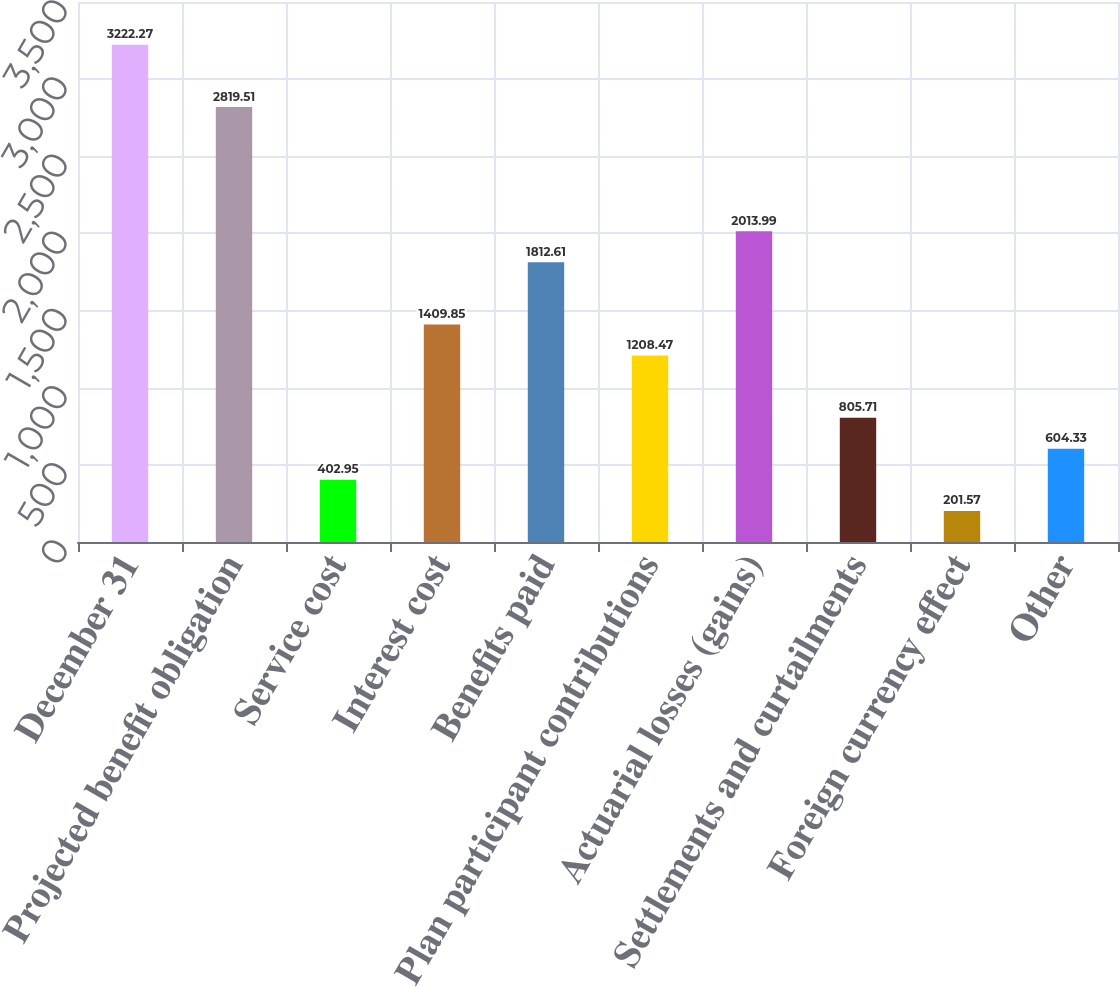Convert chart to OTSL. <chart><loc_0><loc_0><loc_500><loc_500><bar_chart><fcel>December 31<fcel>Projected benefit obligation<fcel>Service cost<fcel>Interest cost<fcel>Benefits paid<fcel>Plan participant contributions<fcel>Actuarial losses (gains)<fcel>Settlements and curtailments<fcel>Foreign currency effect<fcel>Other<nl><fcel>3222.27<fcel>2819.51<fcel>402.95<fcel>1409.85<fcel>1812.61<fcel>1208.47<fcel>2013.99<fcel>805.71<fcel>201.57<fcel>604.33<nl></chart> 